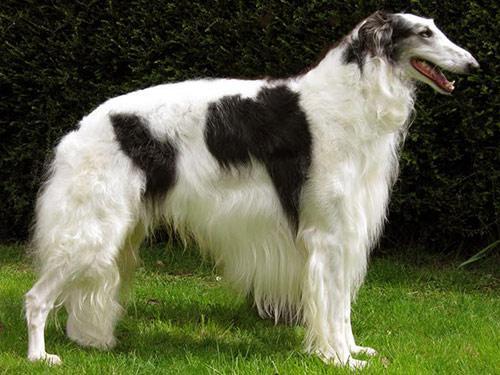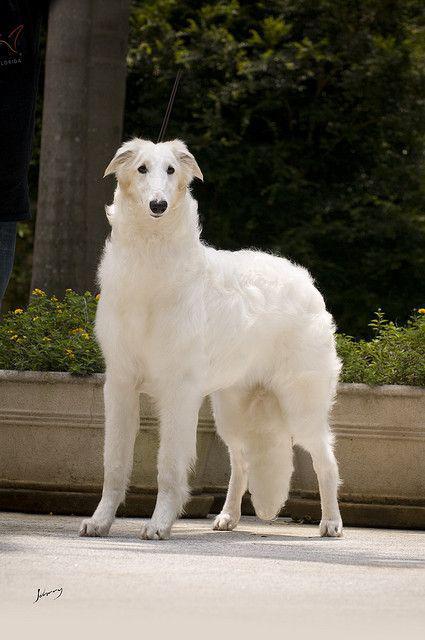The first image is the image on the left, the second image is the image on the right. Considering the images on both sides, is "The dog in the left image is facing towards the left." valid? Answer yes or no. No. The first image is the image on the left, the second image is the image on the right. For the images shown, is this caption "Each image contains exactly one long-haired hound standing outdoors on all fours." true? Answer yes or no. Yes. 